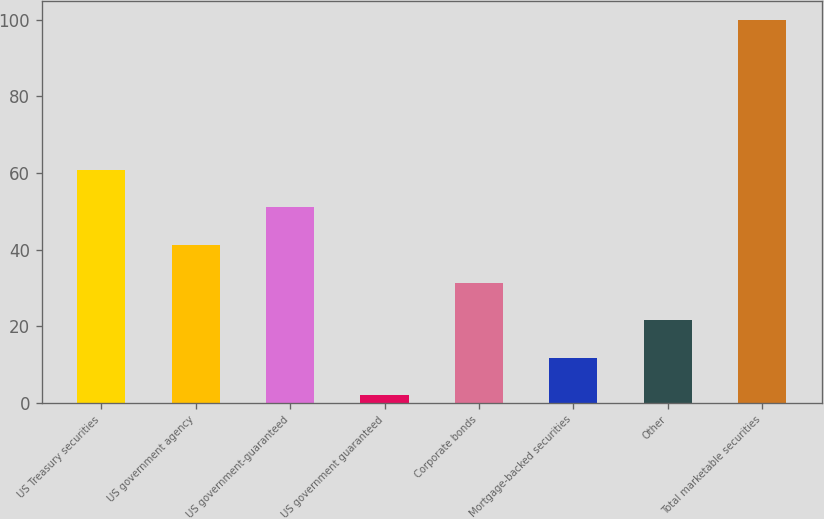<chart> <loc_0><loc_0><loc_500><loc_500><bar_chart><fcel>US Treasury securities<fcel>US government agency<fcel>US government-guaranteed<fcel>US government guaranteed<fcel>Corporate bonds<fcel>Mortgage-backed securities<fcel>Other<fcel>Total marketable securities<nl><fcel>60.8<fcel>41.2<fcel>51<fcel>2<fcel>31.4<fcel>11.8<fcel>21.6<fcel>100<nl></chart> 